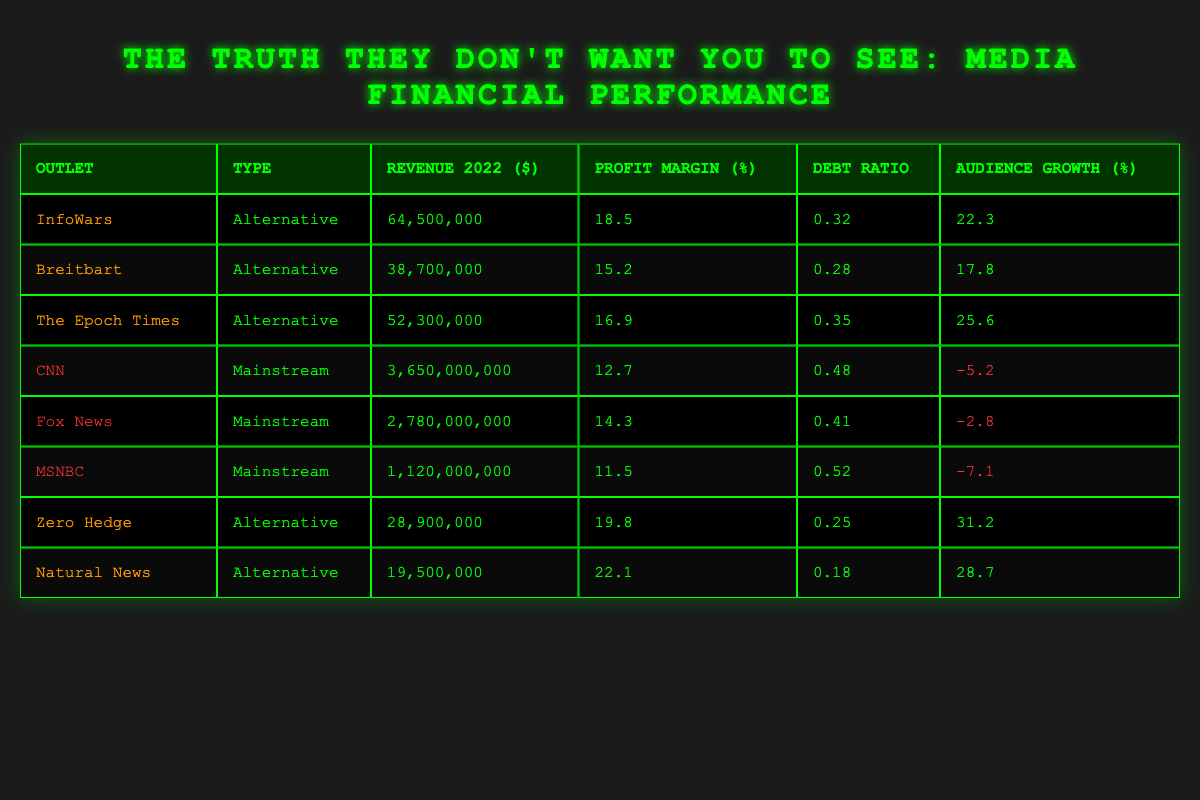What is the revenue of InfoWars in 2022? The revenue for InfoWars is listed in the table under the "Revenue 2022 ($)" column, which shows $64,500,000.
Answer: 64,500,000 Which outlet has the highest profit margin? By examining the "Profit Margin (%)" column, we see that Natural News has the highest profit margin at 22.1%.
Answer: Natural News What is the average audience growth for mainstream media outlets? The audience growth percentages for mainstream outlets are -5.2 (CNN), -2.8 (Fox News), and -7.1 (MSNBC). Summing these values gives -15.1, and dividing by 3 (the number of outlets) results in an average of -5.03%.
Answer: -5.03% Is Zero Hedge an alternative media outlet? Zero Hedge is classified under the "Type" column as Alternative, confirming that it is indeed an alternative media outlet.
Answer: Yes How much more revenue did CNN generate compared to the total revenue of all alternative outlets? The total revenue for the alternative media outlets is the sum of their revenues: 64,500,000 (InfoWars) + 38,700,000 (Breitbart) + 52,300,000 (The Epoch Times) + 28,900,000 (Zero Hedge) + 19,500,000 (Natural News), which equals 204,900,000. CNN's revenue is 3,650,000,000. Therefore, the difference is 3,650,000,000 - 204,900,000 = 3,445,100,000.
Answer: 3,445,100,000 What percentage of the total revenues of alternative media outlets comes from InfoWars? The total revenue of alternative outlets is 204,900,000. InfoWars revenue is 64,500,000. To find the percentage, calculate (64,500,000 / 204,900,000) * 100, which is approximately 31.5%.
Answer: 31.5% 